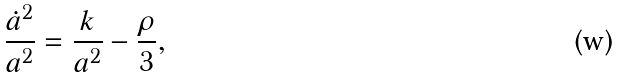<formula> <loc_0><loc_0><loc_500><loc_500>\frac { \dot { a } ^ { 2 } } { a ^ { 2 } } = \frac { k } { a ^ { 2 } } - \frac { \rho } { 3 } ,</formula> 